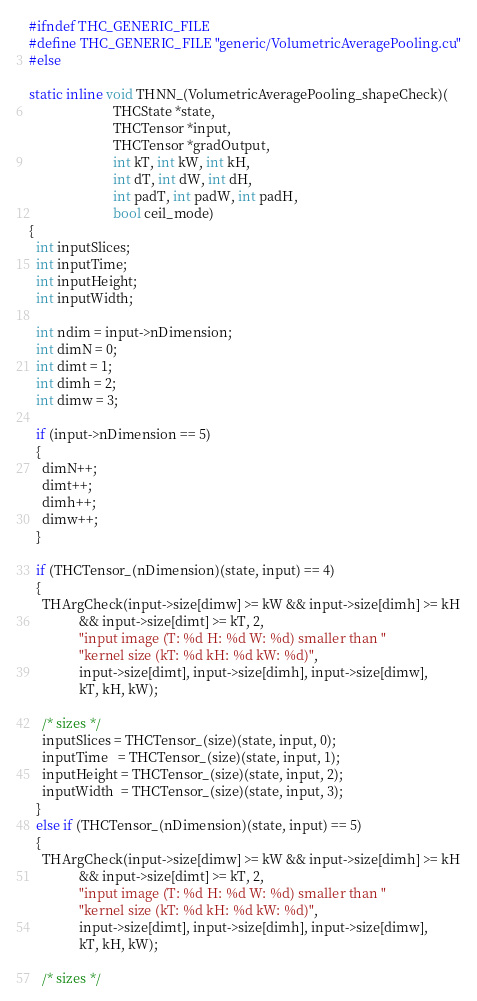Convert code to text. <code><loc_0><loc_0><loc_500><loc_500><_Cuda_>#ifndef THC_GENERIC_FILE
#define THC_GENERIC_FILE "generic/VolumetricAveragePooling.cu"
#else

static inline void THNN_(VolumetricAveragePooling_shapeCheck)(
                         THCState *state,
                         THCTensor *input,
                         THCTensor *gradOutput,
                         int kT, int kW, int kH,
                         int dT, int dW, int dH,
                         int padT, int padW, int padH,
                         bool ceil_mode)
{
  int inputSlices;
  int inputTime;
  int inputHeight;
  int inputWidth;

  int ndim = input->nDimension;
  int dimN = 0;
  int dimt = 1;
  int dimh = 2;
  int dimw = 3;

  if (input->nDimension == 5)
  {
    dimN++;
    dimt++;
    dimh++;
    dimw++;
  }

  if (THCTensor_(nDimension)(state, input) == 4)
  {
    THArgCheck(input->size[dimw] >= kW && input->size[dimh] >= kH
               && input->size[dimt] >= kT, 2,
               "input image (T: %d H: %d W: %d) smaller than "
               "kernel size (kT: %d kH: %d kW: %d)",
               input->size[dimt], input->size[dimh], input->size[dimw],
               kT, kH, kW);

    /* sizes */
    inputSlices = THCTensor_(size)(state, input, 0);
    inputTime   = THCTensor_(size)(state, input, 1);
    inputHeight = THCTensor_(size)(state, input, 2);
    inputWidth  = THCTensor_(size)(state, input, 3);
  }
  else if (THCTensor_(nDimension)(state, input) == 5)
  {
    THArgCheck(input->size[dimw] >= kW && input->size[dimh] >= kH
               && input->size[dimt] >= kT, 2,
               "input image (T: %d H: %d W: %d) smaller than "
               "kernel size (kT: %d kH: %d kW: %d)",
               input->size[dimt], input->size[dimh], input->size[dimw],
               kT, kH, kW);

    /* sizes */</code> 